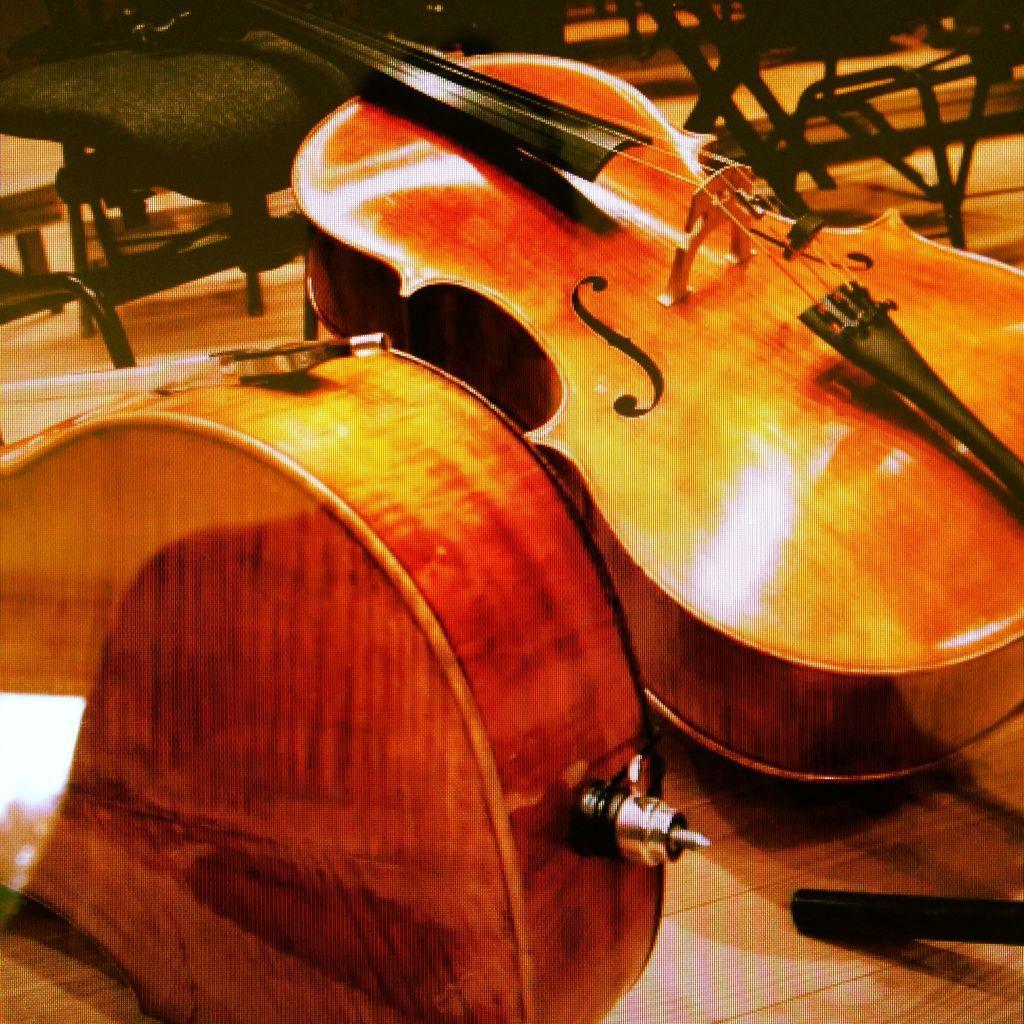Describe this image in one or two sentences. In this picture there are two violins. In the background there are many chairs. On the violin a letter S is written. 